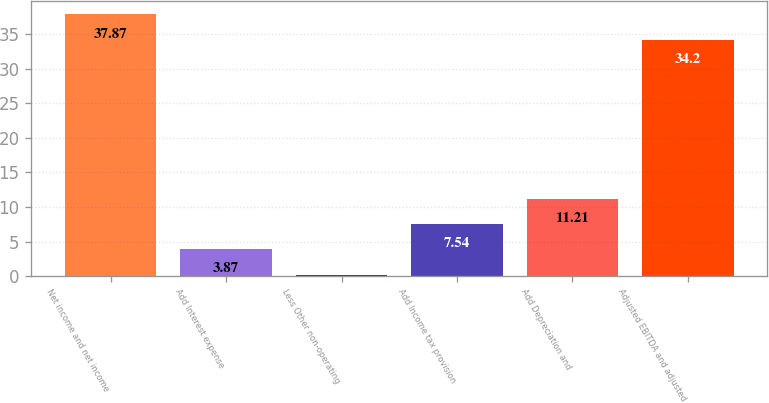Convert chart. <chart><loc_0><loc_0><loc_500><loc_500><bar_chart><fcel>Net income and net income<fcel>Add Interest expense<fcel>Less Other non-operating<fcel>Add Income tax provision<fcel>Add Depreciation and<fcel>Adjusted EBITDA and adjusted<nl><fcel>37.87<fcel>3.87<fcel>0.2<fcel>7.54<fcel>11.21<fcel>34.2<nl></chart> 